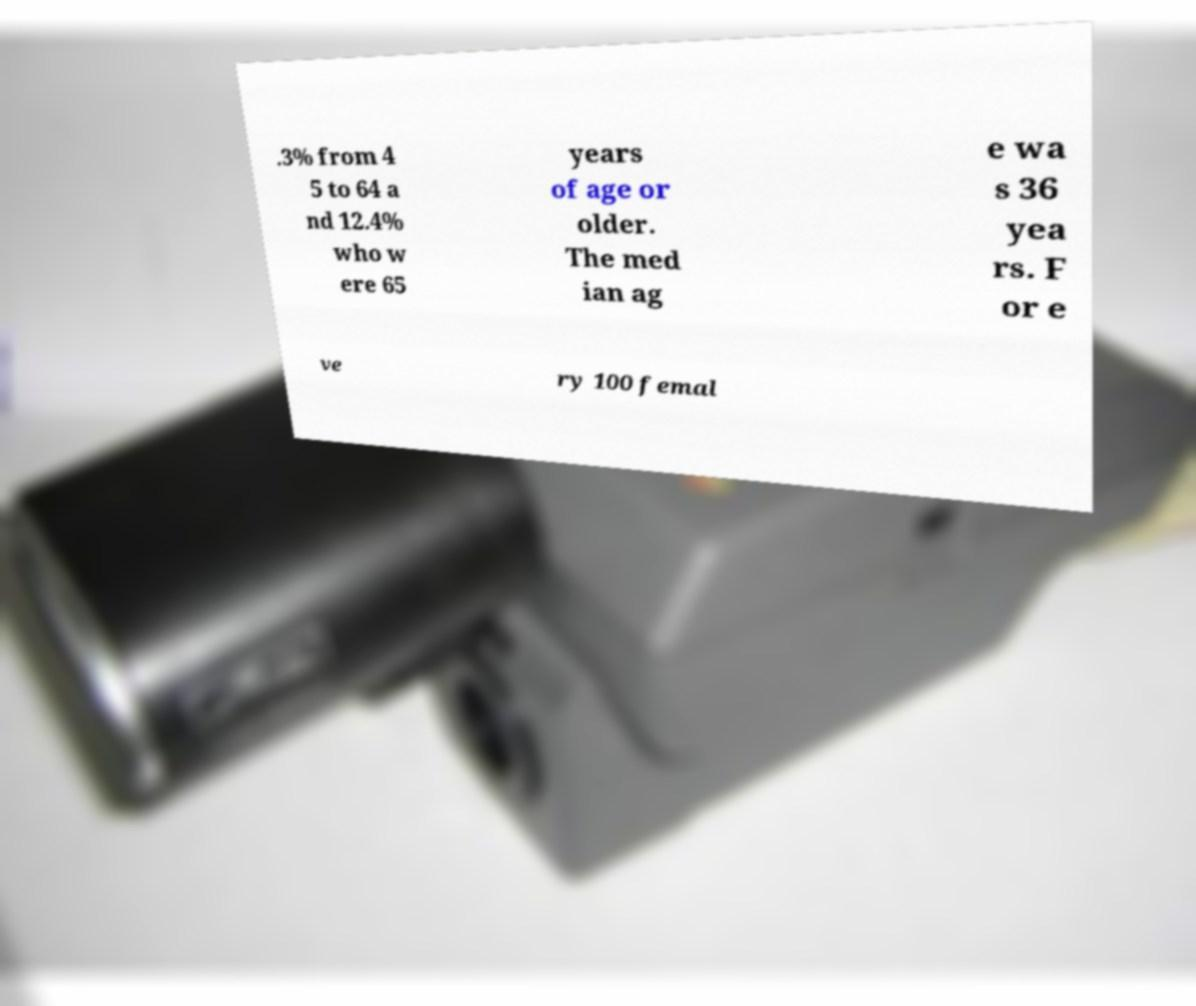Please read and relay the text visible in this image. What does it say? .3% from 4 5 to 64 a nd 12.4% who w ere 65 years of age or older. The med ian ag e wa s 36 yea rs. F or e ve ry 100 femal 